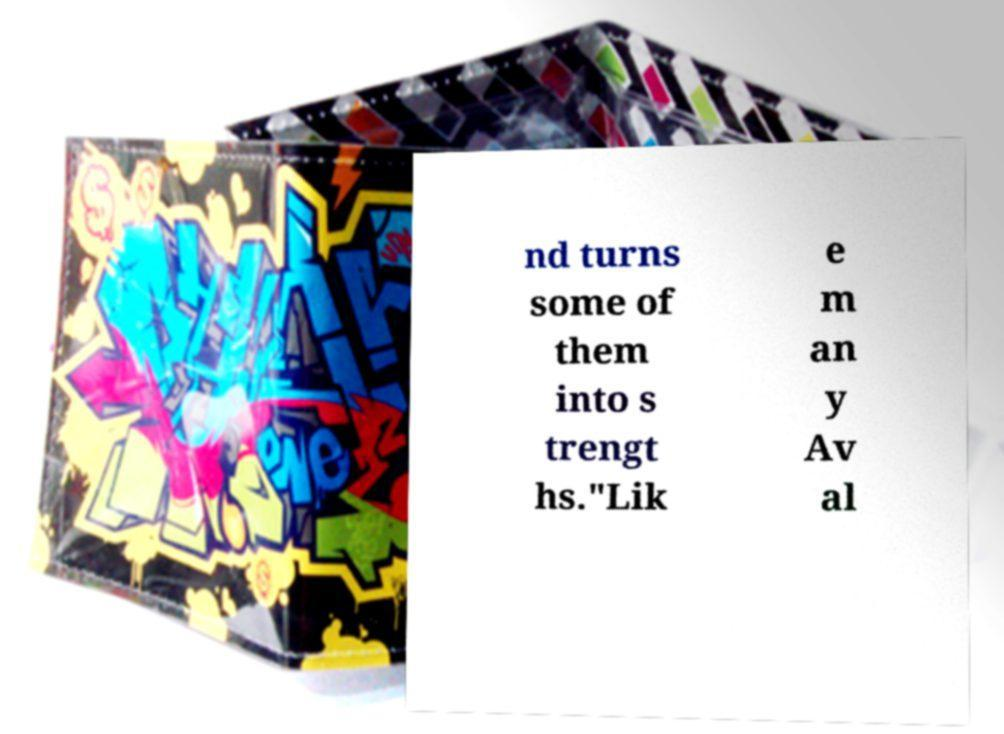Could you extract and type out the text from this image? nd turns some of them into s trengt hs."Lik e m an y Av al 